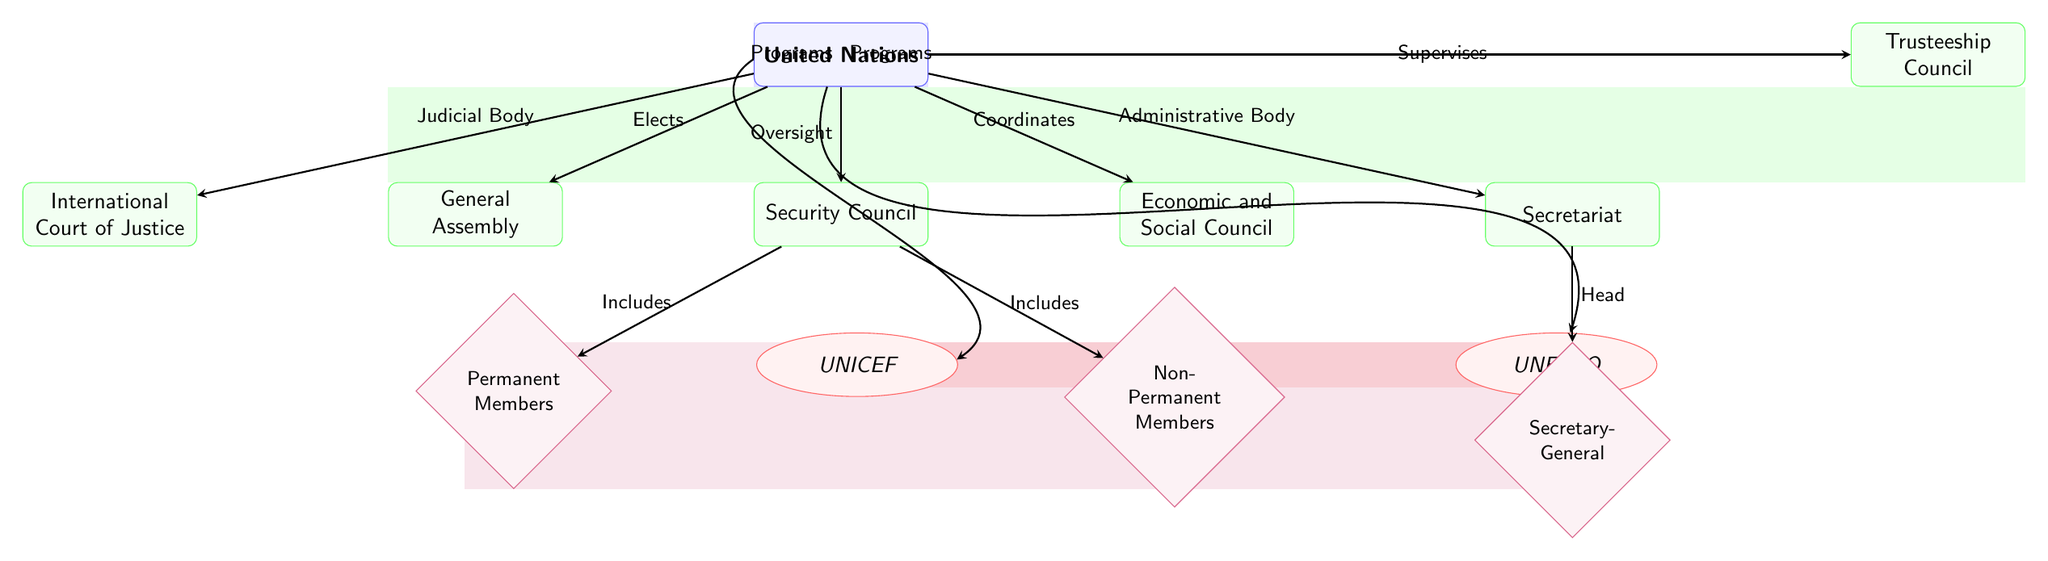What is the main entity in the diagram? The diagram identifies the "United Nations" as the main entity, indicated at the top of the chart.
Answer: United Nations How many major UN bodies are represented in the diagram? There are five major UN bodies depicted in the diagram: General Assembly, Security Council, Economic and Social Council, International Court of Justice, and Secretariat.
Answer: Five What role do Permanent Members hold in the Security Council? The diagram indicates that Permanent Members are included in the Security Council, suggesting their influential and continual presence in decision-making.
Answer: Includes Which body coordinates the Economic and Social Council? The diagram shows that the United Nations coordinates the Economic and Social Council, indicated by the arrow connecting them.
Answer: United Nations What is the function of the Secretary-General in the UN structure? According to the diagram, the Secretary-General is designated as the head of the Secretariat, indicating the leadership position and role in administration.
Answer: Head Which two agencies are connected to the Economic and Social Council? The diagram reveals that UNICEF and UNESCO are connected to the Economic and Social Council, highlighting their specific roles within the UN structure.
Answer: UNICEF and UNESCO What does the Trusteeship Council do in relation to the United Nations? The diagram indicates that the Trusteeship Council supervises under the authority of the United Nations, suggesting its oversight responsibilities.
Answer: Supervises What is the relationship between the Security Council and Non-Permanent Members? The diagram illustrates that Non-Permanent Members are included in the Security Council, reflecting their temporary role in decision-making processes within that body.
Answer: Includes How does the diagram depict the role of the International Court of Justice? The diagram states that the International Court of Justice serves as a judicial body under the authority of the United Nations, delineating its legal function.
Answer: Judicial Body 